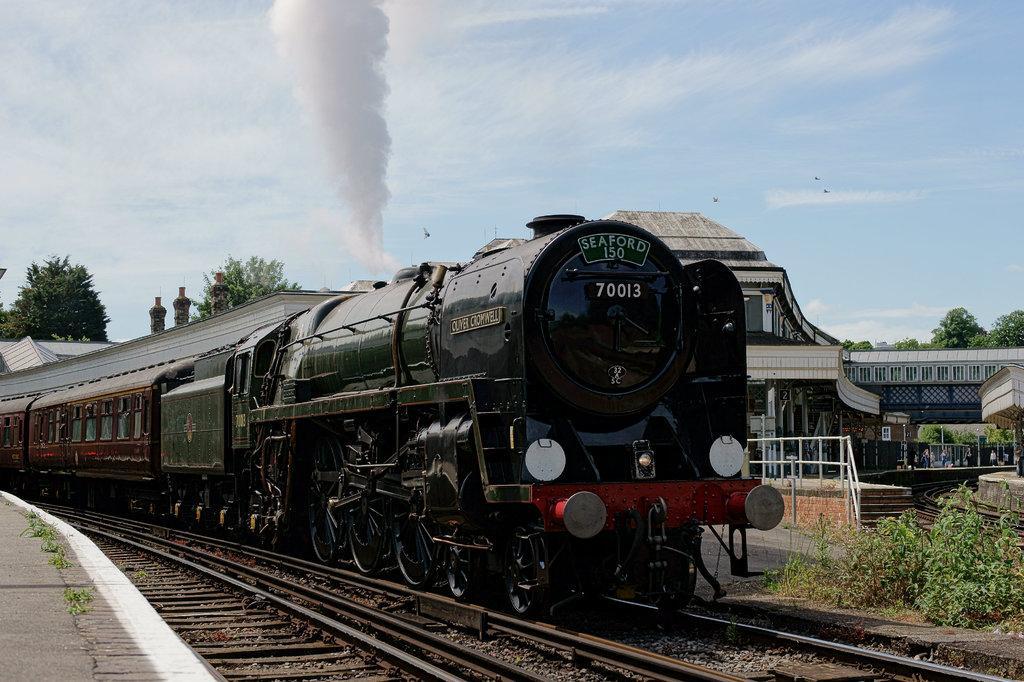Please provide a concise description of this image. In the picture I can see a steam engine is moving on railway track, here we can see the platform, smoke, plants, fence, house, trees and the blue color sky with clouds in the background. 